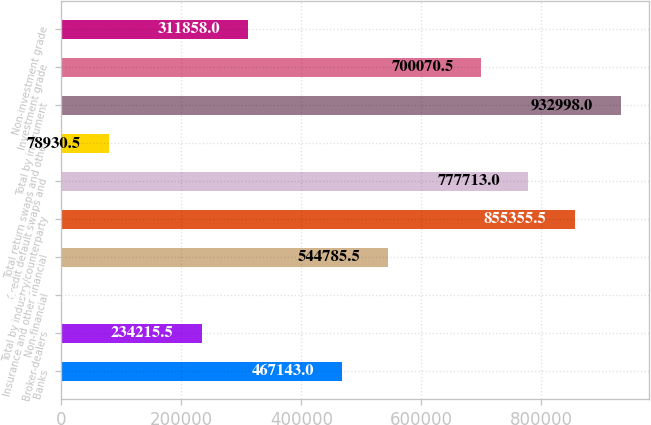Convert chart. <chart><loc_0><loc_0><loc_500><loc_500><bar_chart><fcel>Banks<fcel>Broker-dealers<fcel>Non-financial<fcel>Insurance and other financial<fcel>Total by industry/counterparty<fcel>Credit default swaps and<fcel>Total return swaps and other<fcel>Total by instrument<fcel>Investment grade<fcel>Non-investment grade<nl><fcel>467143<fcel>234216<fcel>1288<fcel>544786<fcel>855356<fcel>777713<fcel>78930.5<fcel>932998<fcel>700070<fcel>311858<nl></chart> 